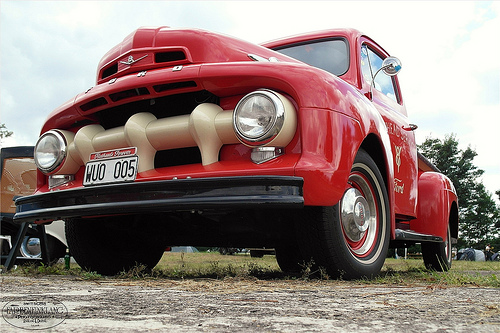<image>
Is the road in the car? No. The road is not contained within the car. These objects have a different spatial relationship. 